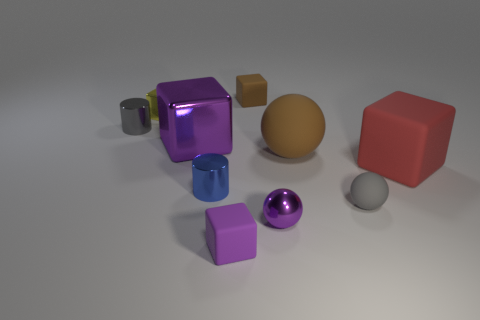Subtract all brown matte cubes. How many cubes are left? 4 Subtract all gray cylinders. How many cylinders are left? 1 Subtract 2 cubes. How many cubes are left? 3 Subtract all purple spheres. Subtract all blue blocks. How many spheres are left? 2 Subtract all green blocks. How many red cylinders are left? 0 Subtract all tiny blue metal objects. Subtract all large brown balls. How many objects are left? 8 Add 5 small purple matte things. How many small purple matte things are left? 6 Add 2 tiny gray things. How many tiny gray things exist? 4 Subtract 0 gray blocks. How many objects are left? 10 Subtract all cylinders. How many objects are left? 8 